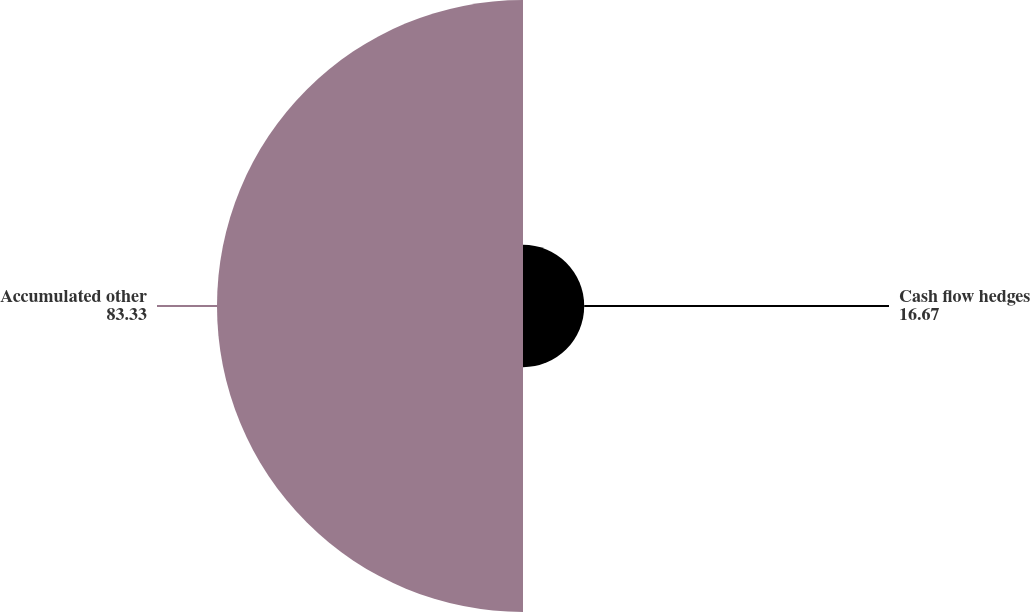Convert chart to OTSL. <chart><loc_0><loc_0><loc_500><loc_500><pie_chart><fcel>Cash flow hedges<fcel>Accumulated other<nl><fcel>16.67%<fcel>83.33%<nl></chart> 